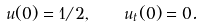<formula> <loc_0><loc_0><loc_500><loc_500>u ( 0 ) = 1 / 2 , \quad u _ { t } ( 0 ) = 0 .</formula> 